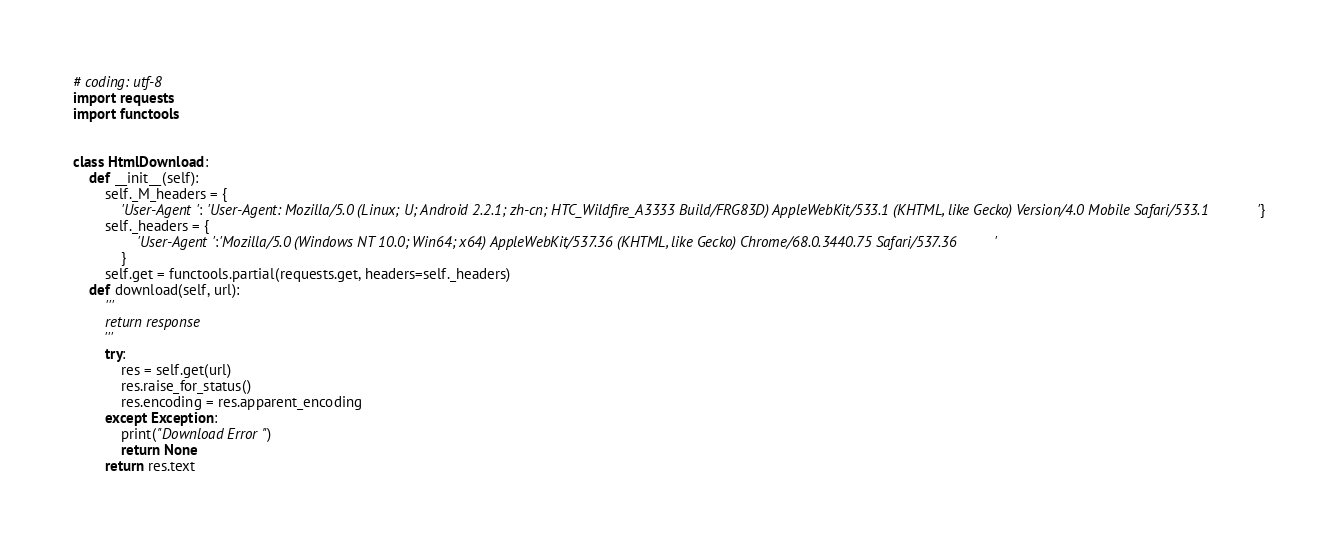Convert code to text. <code><loc_0><loc_0><loc_500><loc_500><_Python_># coding: utf-8
import requests
import functools


class HtmlDownload:
    def __init__(self):
        self._M_headers = {
            'User-Agent': 'User-Agent: Mozilla/5.0 (Linux; U; Android 2.2.1; zh-cn; HTC_Wildfire_A3333 Build/FRG83D) AppleWebKit/533.1 (KHTML, like Gecko) Version/4.0 Mobile Safari/533.1'}
        self._headers = {
                'User-Agent':'Mozilla/5.0 (Windows NT 10.0; Win64; x64) AppleWebKit/537.36 (KHTML, like Gecko) Chrome/68.0.3440.75 Safari/537.36'
            }
        self.get = functools.partial(requests.get, headers=self._headers)
    def download(self, url):
        '''
        return response
        '''
        try:
            res = self.get(url)
            res.raise_for_status()
            res.encoding = res.apparent_encoding
        except Exception:
            print("Download Error")
            return None
        return res.text</code> 